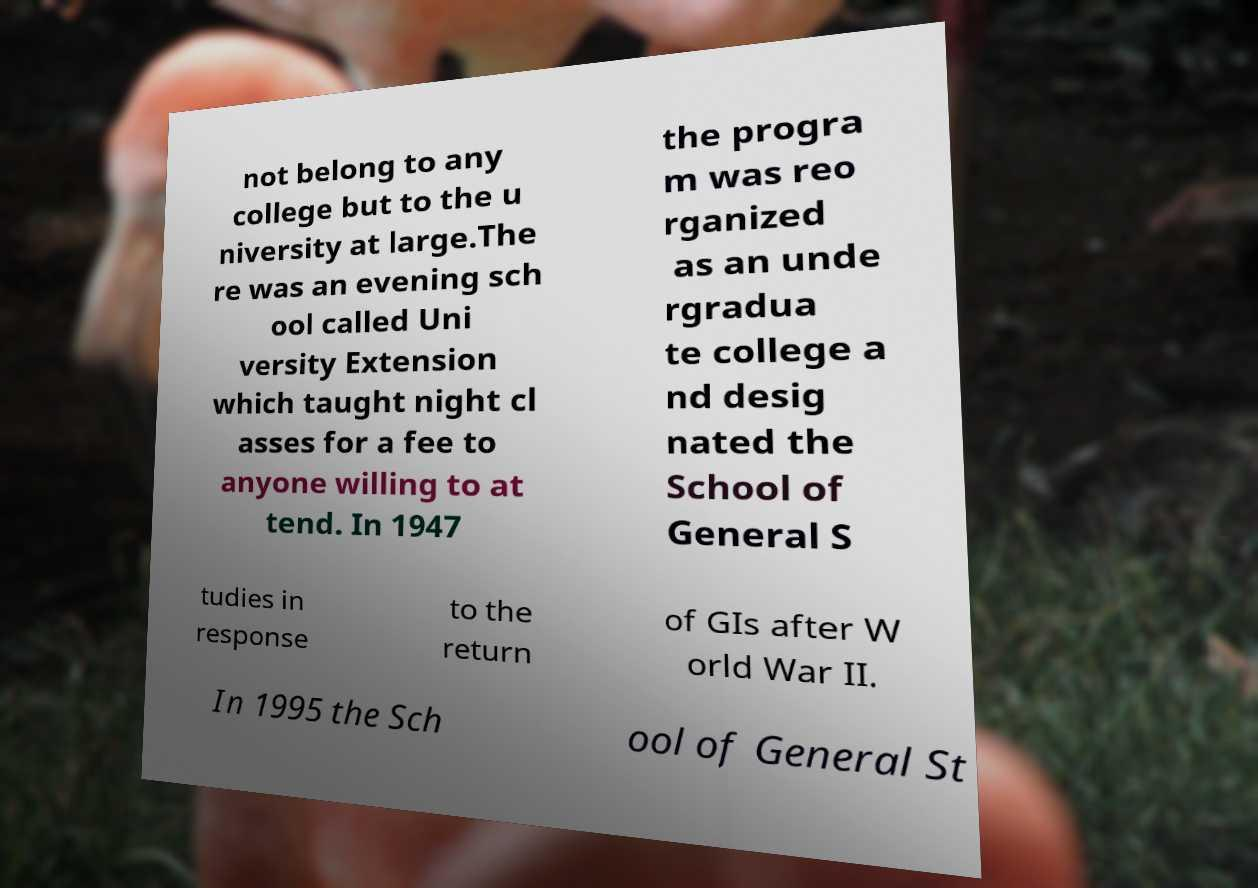Could you extract and type out the text from this image? not belong to any college but to the u niversity at large.The re was an evening sch ool called Uni versity Extension which taught night cl asses for a fee to anyone willing to at tend. In 1947 the progra m was reo rganized as an unde rgradua te college a nd desig nated the School of General S tudies in response to the return of GIs after W orld War II. In 1995 the Sch ool of General St 